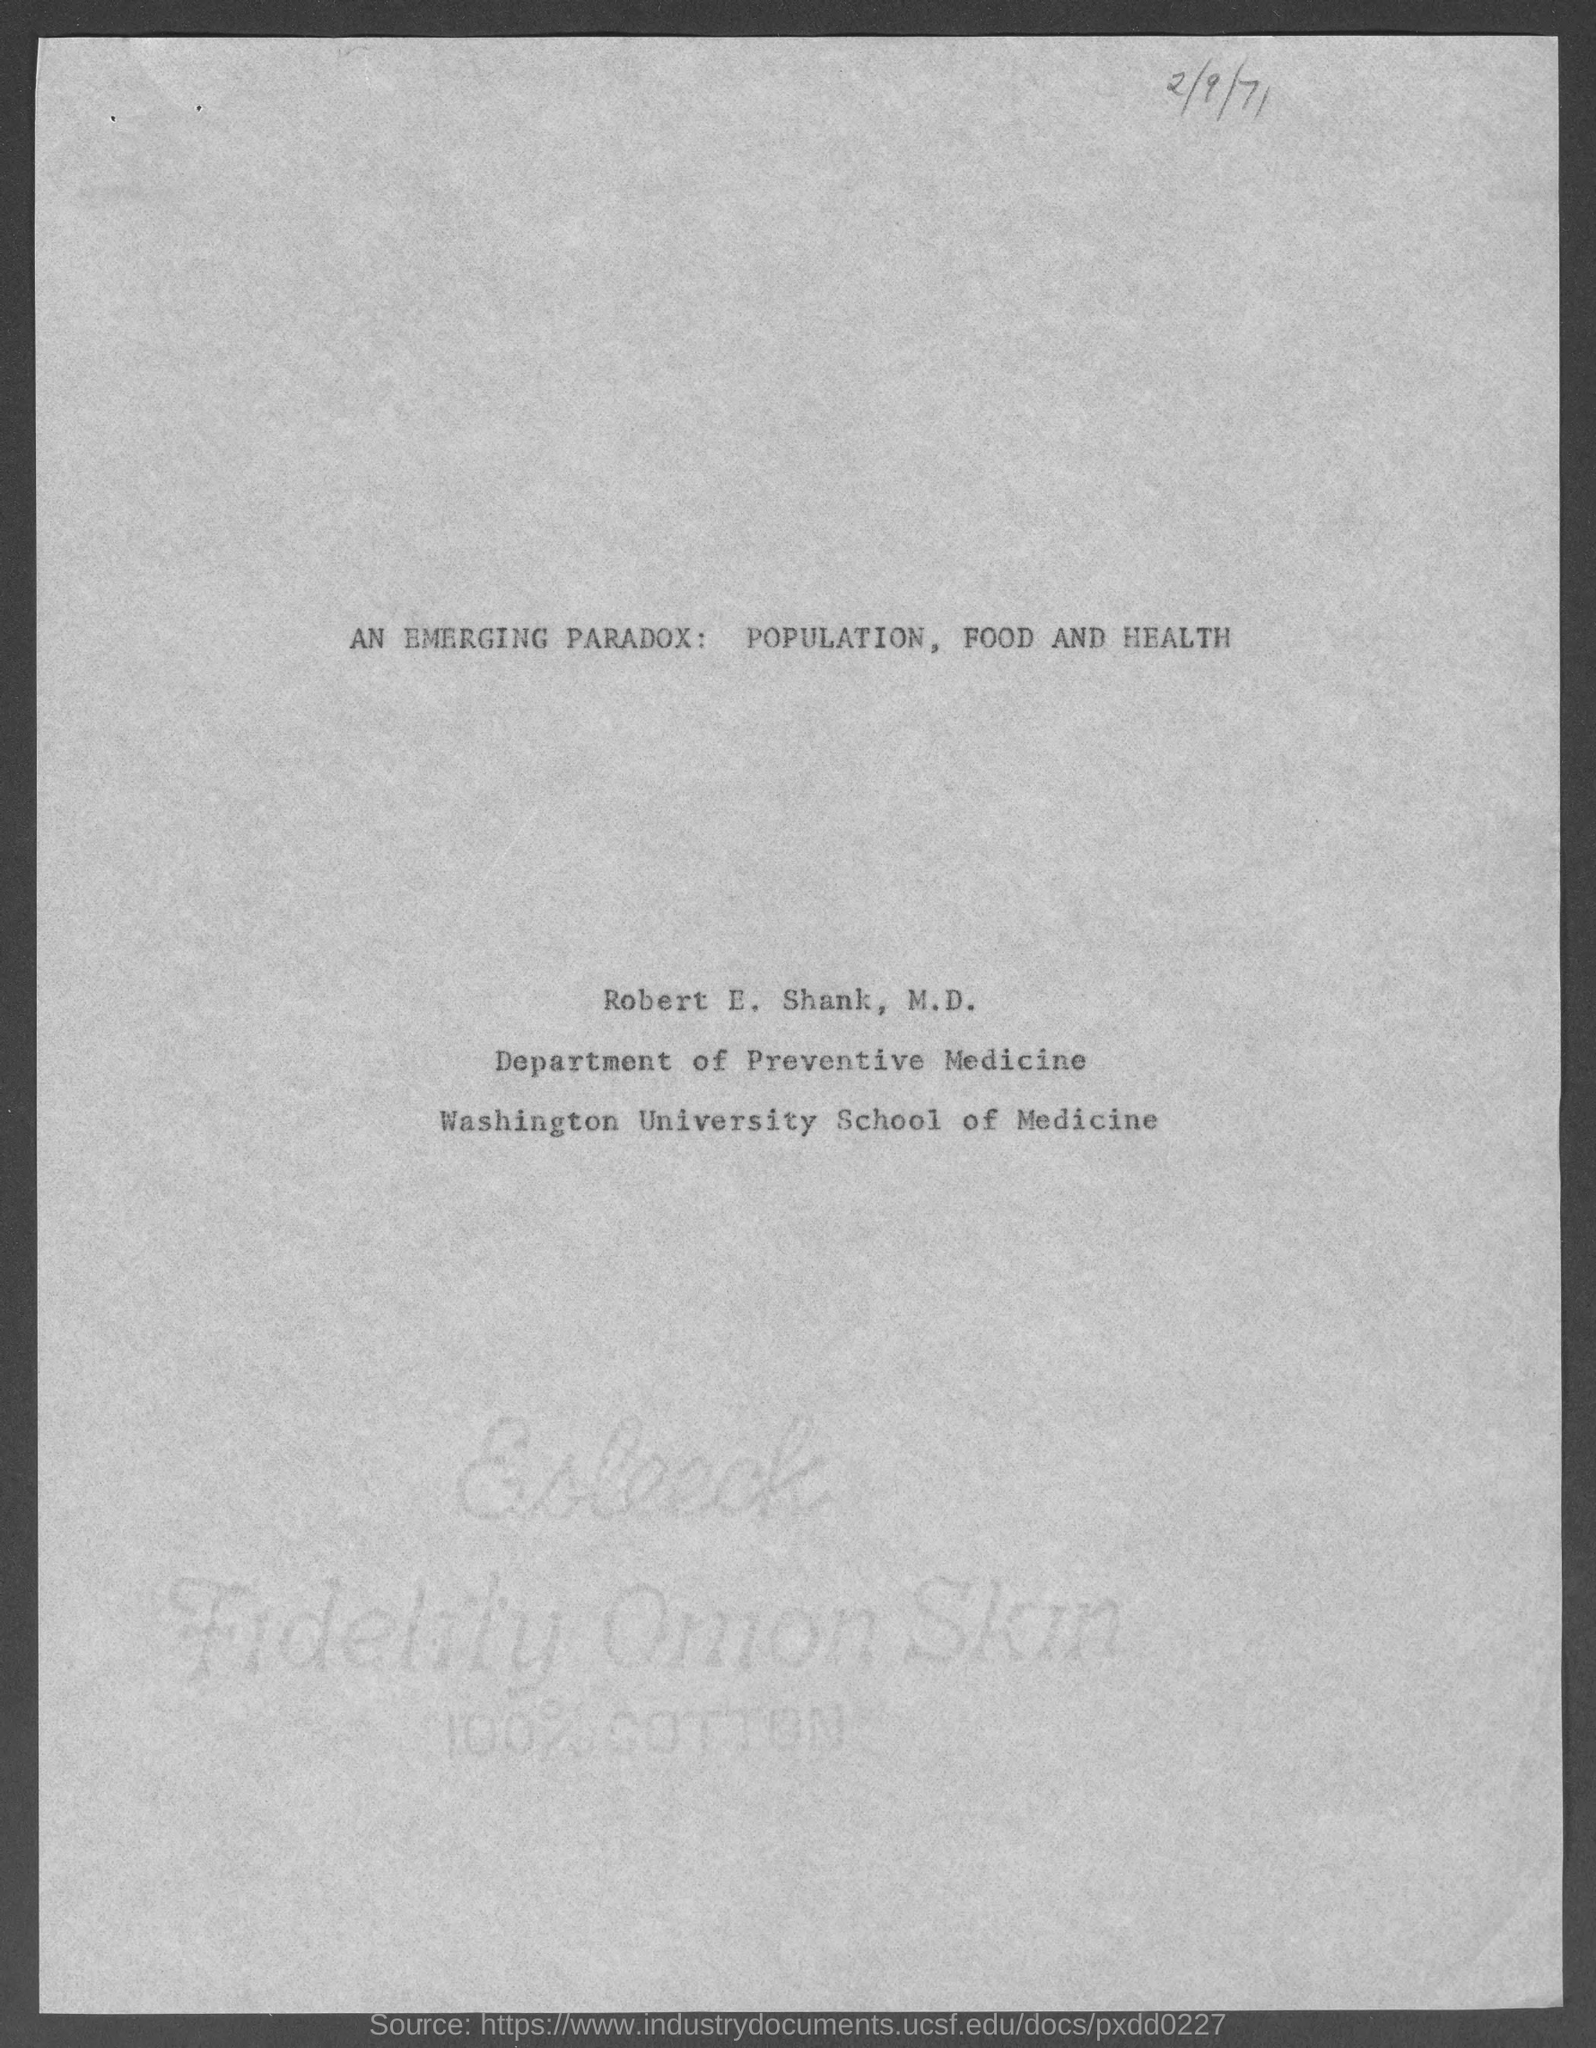In which deparment, Robert E. Shank, M.D. works?
Your response must be concise. Department of Preventive Medicine. What is the date mentioned in this document?
Provide a succinct answer. 2/9/71. 